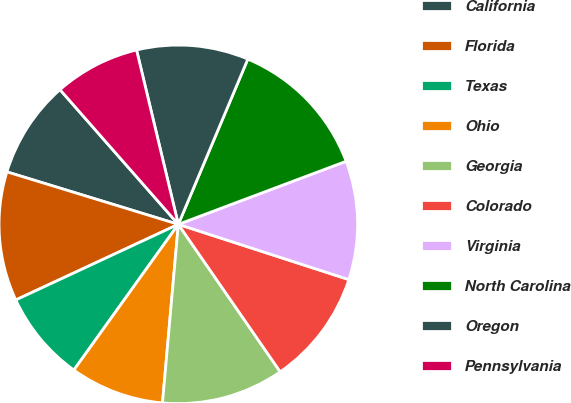Convert chart. <chart><loc_0><loc_0><loc_500><loc_500><pie_chart><fcel>California<fcel>Florida<fcel>Texas<fcel>Ohio<fcel>Georgia<fcel>Colorado<fcel>Virginia<fcel>North Carolina<fcel>Oregon<fcel>Pennsylvania<nl><fcel>8.8%<fcel>11.66%<fcel>8.17%<fcel>8.49%<fcel>11.03%<fcel>10.39%<fcel>10.71%<fcel>12.94%<fcel>10.08%<fcel>7.73%<nl></chart> 